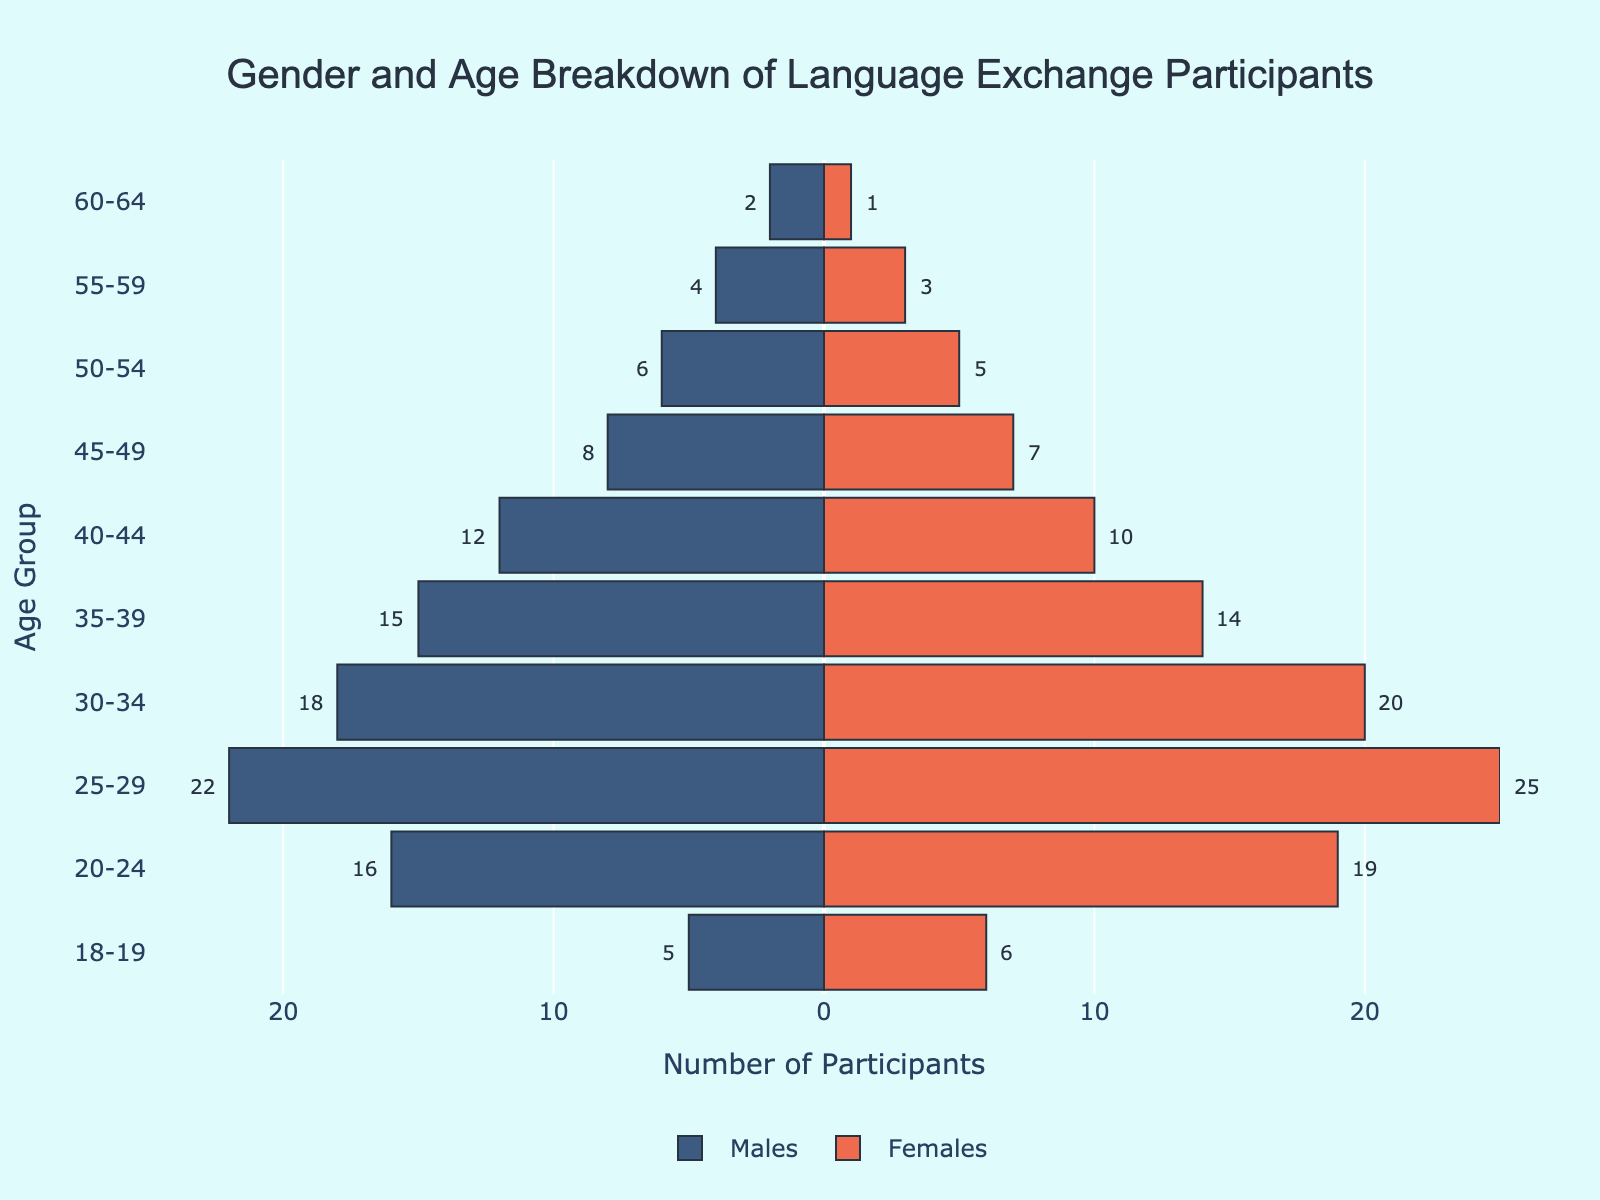What's the title of the figure? The title is displayed at the top of the figure, centered. It reads: "Gender and Age Breakdown of Language Exchange Participants".
Answer: Gender and Age Breakdown of Language Exchange Participants What is the age group with the highest number of female participants? Looking at the right side of the plot, the bar for the 25-29 age group extends the farthest to the right, indicating the highest number of female participants.
Answer: 25-29 Which age group has an equal number of male and female participants? Inspecting the lengths of the bars on both sides, the 50-54 age group appears to have one bar slightly longer than the other (6 Males vs 5 Females). Consequently, there is no age group with an equal number of male and female participants.
Answer: None How many more participants are there in the 30-34 age group compared to the 18-19 age group? For the 30-34 group, adding males (18) and females (20) gives 38. For the 18-19 group, adding males (5) and females (6) gives 11. The difference is 38 - 11.
Answer: 27 Which gender has more participants in the 40-44 age group, and by how many? Comparing the bars for males (12) and females (10) in the 40-44 age group, males are greater by 2 participants.
Answer: Males, by 2 Identify the age group with the largest total number of participants. Adding the numbers of males and females for each age group, the 25-29 age group has 22 males and 25 females, totaling 47, which is the highest sum among the groups.
Answer: 25-29 What is the overall trend in participation from younger to older age groups for both genders? Observing the figure from bottom to top, there is a clear trend of decreasing numbers as age increases. Younger groups (20-34) tend to have higher participation compared to older groups (45+).
Answer: Decreasing trend How does the participation of females in the 35-39 age group compare to that of males in the same group? The bar for females in the 35-39 age group extends to 14 participants, while the bar for males extends to 15. Females have 1 less participant than males.
Answer: 1 fewer What is the average number of participants per age group for both genders combined? Summing the total number of participants for each age group gives 121 males and 110 females, making a total of 231 participants. Dividing by the 10 age groups, the average per group is 231 / 10.
Answer: 23.1 participants In which age group is the gender imbalance the greatest, and what is the difference? Examining the difference in the lengths of bars for all age groups, the 20-24 age group shows the greatest imbalance, with males at 16 and females at 19, giving a difference of 3.
Answer: 20-24, by 3 